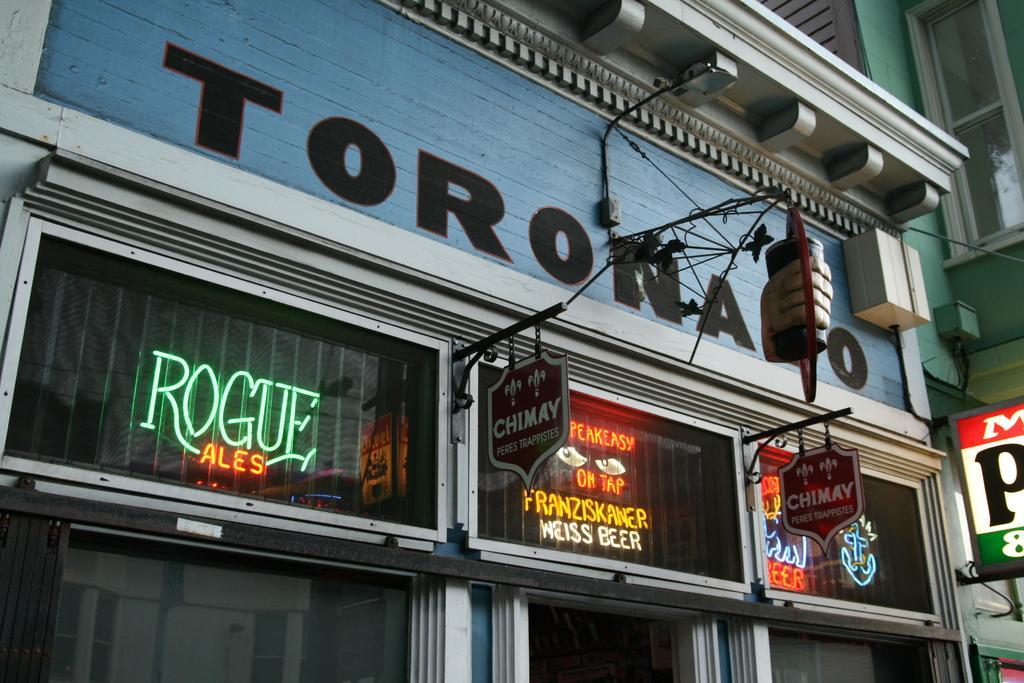How would you summarize this image in a sentence or two? In this image I can see a building , in front of the building I can see some boards attached to the wall and I can see a text written on the building and I can see power line cables visible on the wall of building. 